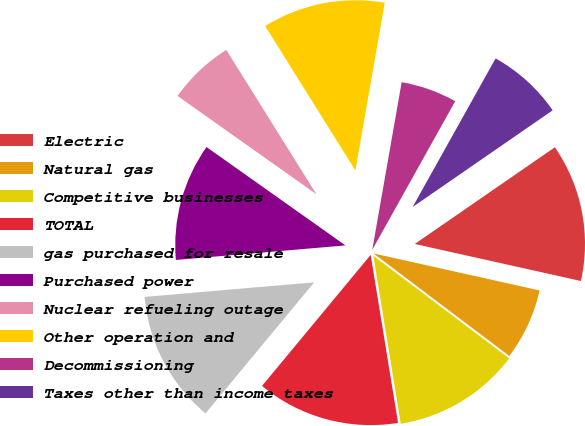<chart> <loc_0><loc_0><loc_500><loc_500><pie_chart><fcel>Electric<fcel>Natural gas<fcel>Competitive businesses<fcel>TOTAL<fcel>gas purchased for resale<fcel>Purchased power<fcel>Nuclear refueling outage<fcel>Other operation and<fcel>Decommissioning<fcel>Taxes other than income taxes<nl><fcel>13.11%<fcel>6.8%<fcel>12.14%<fcel>13.59%<fcel>12.62%<fcel>11.17%<fcel>6.31%<fcel>11.65%<fcel>5.34%<fcel>7.28%<nl></chart> 